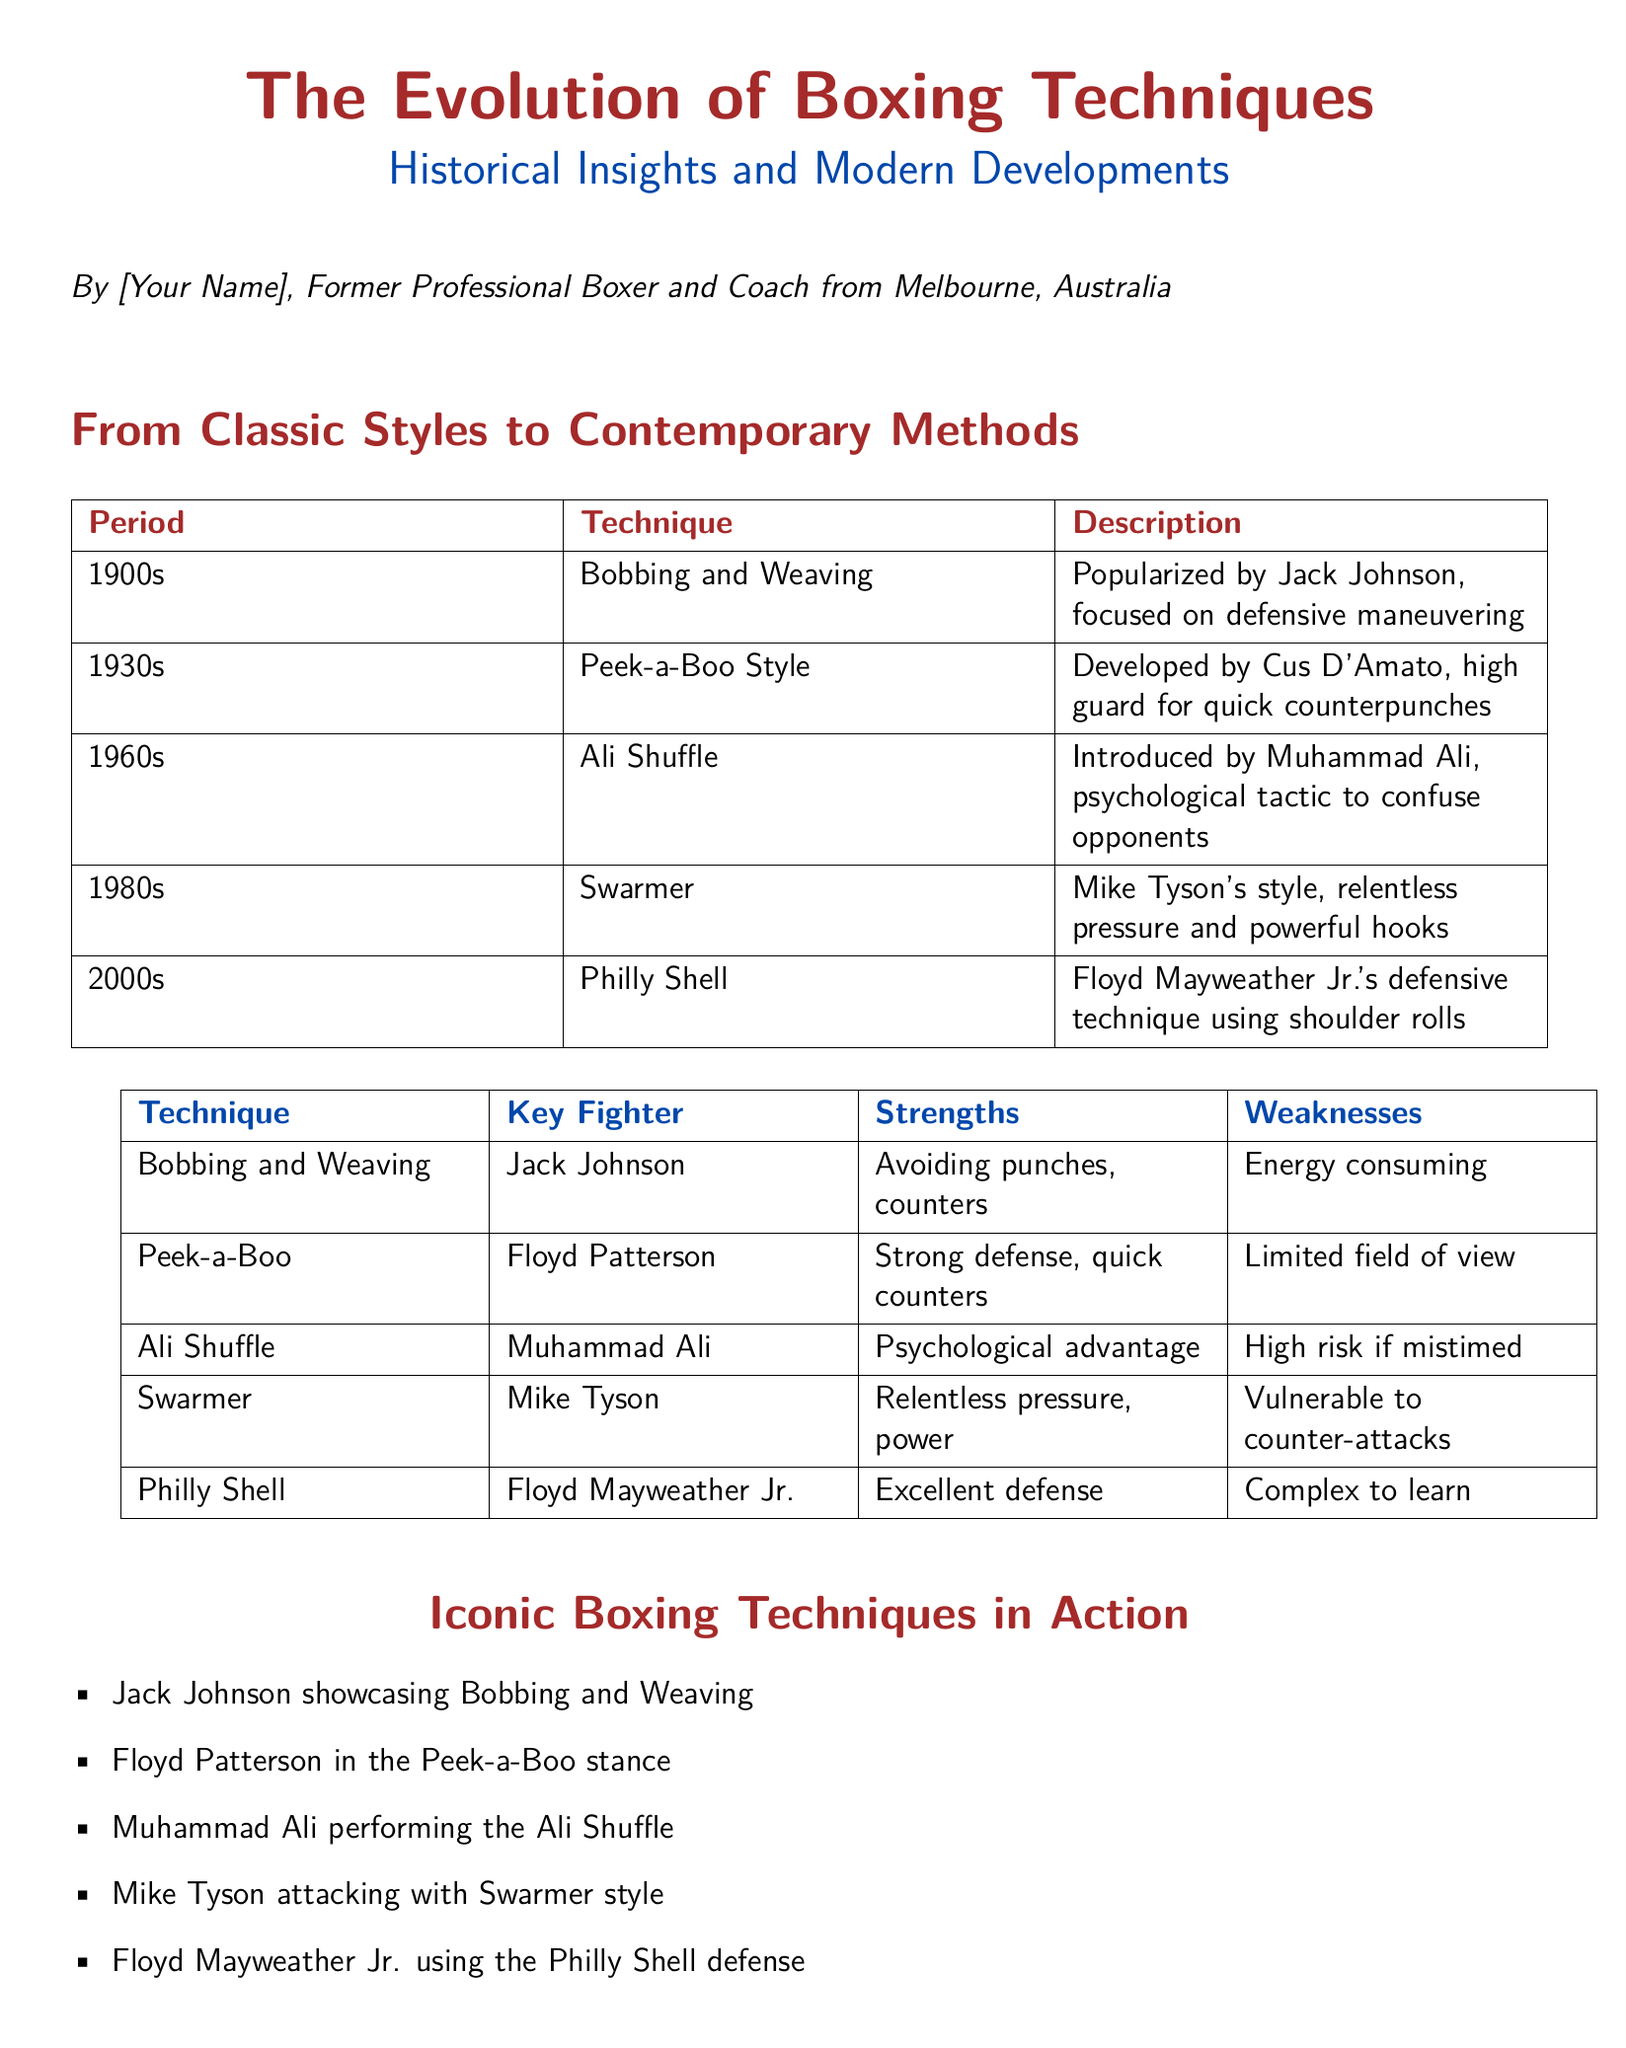What technique did Jack Johnson popularize? The document states that Jack Johnson popularized the Bobbing and Weaving technique.
Answer: Bobbing and Weaving What decade introduced the Ali Shuffle? According to the timeline, the Ali Shuffle was introduced in the 1960s.
Answer: 1960s Who developed the Peek-a-Boo style? The document identifies Cus D'Amato as the developer of the Peek-a-Boo style.
Answer: Cus D'Amato Which fighter is associated with the Swarmer technique? Mike Tyson is identified as the key fighter using the Swarmer technique in the document.
Answer: Mike Tyson What is a weakness of the Philly Shell technique? The document states that a weakness of the Philly Shell is that it is complex to learn.
Answer: Complex to learn What does the document describe about the strength of the Bobbing and Weaving technique? The document describes that the strength of the Bobbing and Weaving technique is avoiding punches and counters.
Answer: Avoiding punches, counters What color is used for section titles in the document? The section titles are styled in a specific shade defined as boxingred.
Answer: Boxingred Which boxing style offers a psychological advantage according to the document? The Ali Shuffle technique is mentioned as offering a psychological advantage.
Answer: Ali Shuffle What type of content is presented alongside the descriptions of boxing techniques? Action-packed photos are mentioned as a type of content that accompanies the boxing techniques descriptions.
Answer: Action-packed photos 